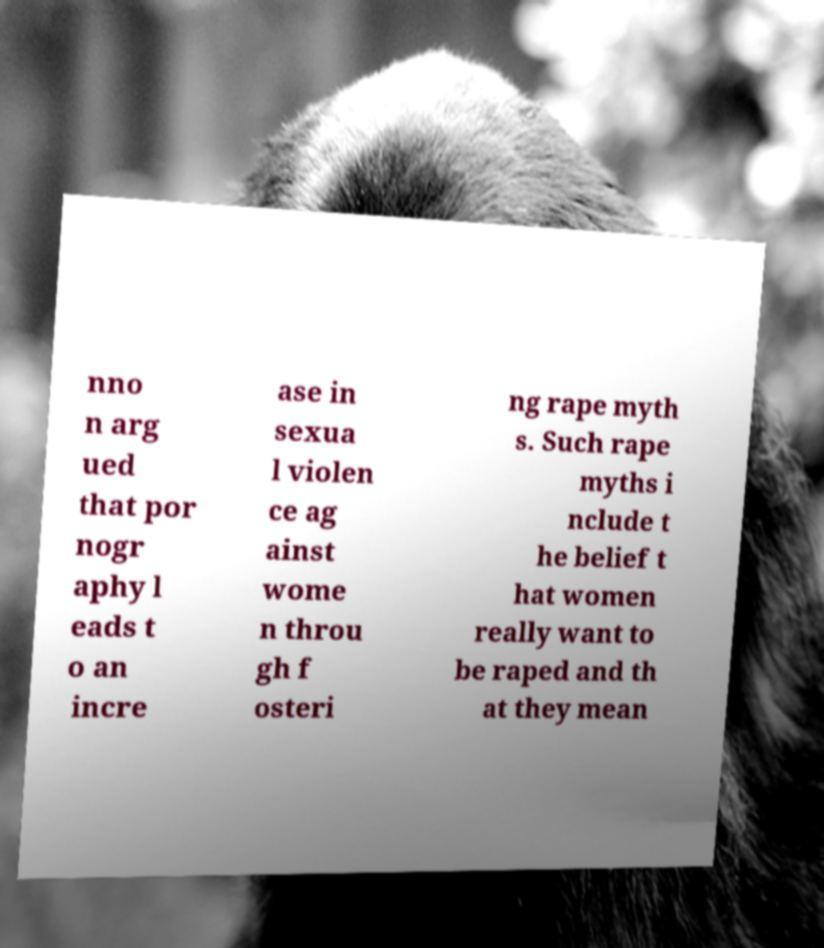What messages or text are displayed in this image? I need them in a readable, typed format. nno n arg ued that por nogr aphy l eads t o an incre ase in sexua l violen ce ag ainst wome n throu gh f osteri ng rape myth s. Such rape myths i nclude t he belief t hat women really want to be raped and th at they mean 